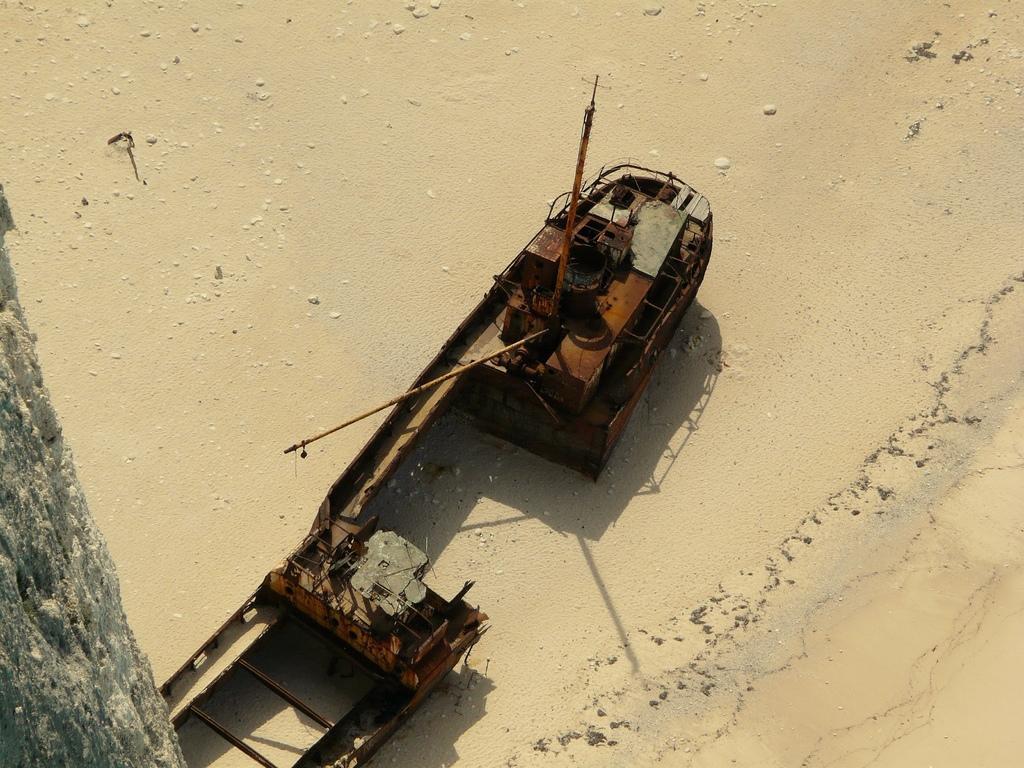In one or two sentences, can you explain what this image depicts? In this image there is a metal structure on the surface of the sand. On the left side of the image there is a stem of a tree. 